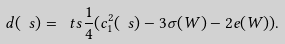Convert formula to latex. <formula><loc_0><loc_0><loc_500><loc_500>d ( \ s ) = \ t s \frac { 1 } { 4 } ( c _ { 1 } ^ { 2 } ( \ s ) - 3 \sigma ( W ) - 2 e ( W ) ) .</formula> 